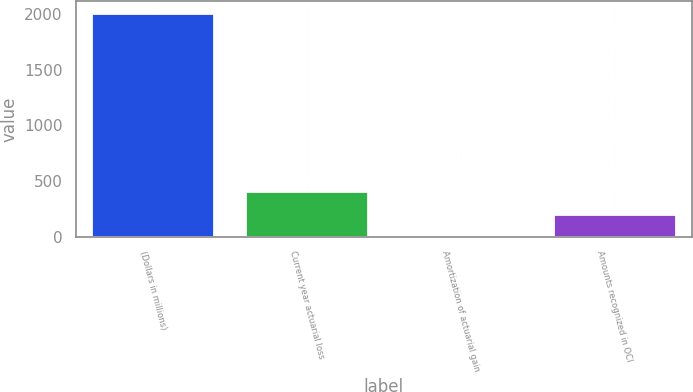Convert chart. <chart><loc_0><loc_0><loc_500><loc_500><bar_chart><fcel>(Dollars in millions)<fcel>Current year actuarial loss<fcel>Amortization of actuarial gain<fcel>Amounts recognized in OCI<nl><fcel>2016<fcel>408<fcel>6<fcel>207<nl></chart> 